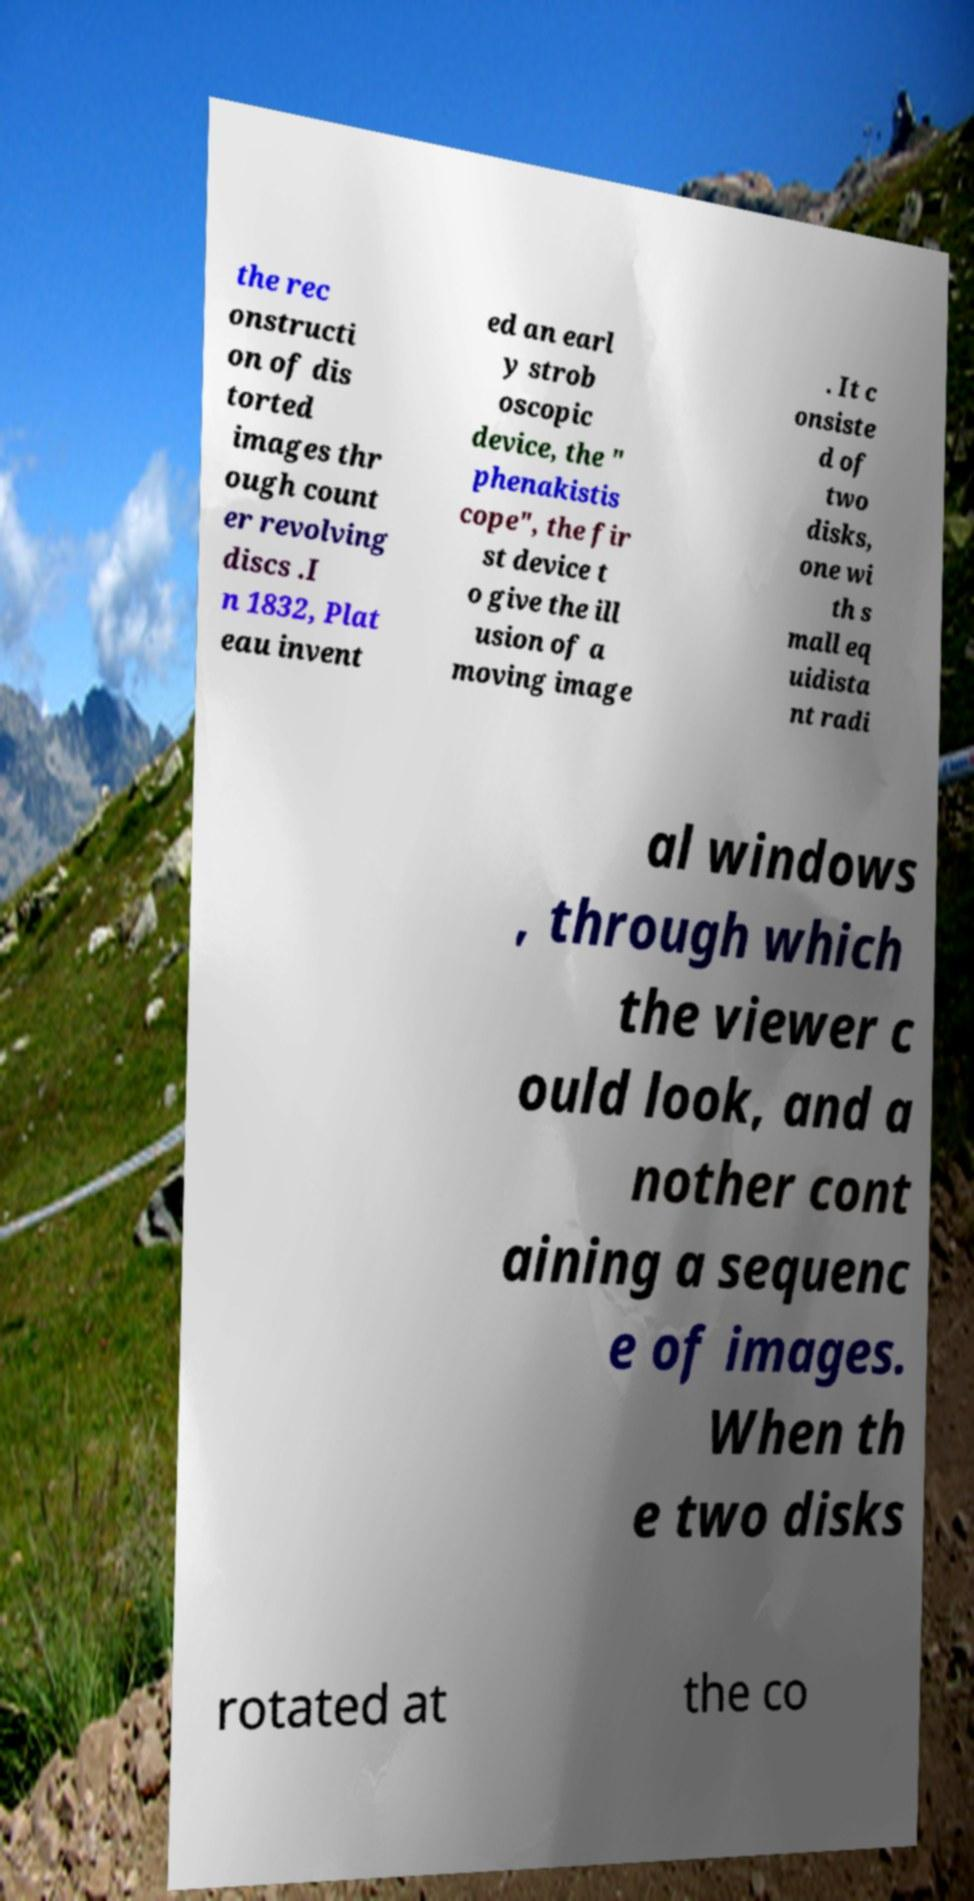What messages or text are displayed in this image? I need them in a readable, typed format. the rec onstructi on of dis torted images thr ough count er revolving discs .I n 1832, Plat eau invent ed an earl y strob oscopic device, the " phenakistis cope", the fir st device t o give the ill usion of a moving image . It c onsiste d of two disks, one wi th s mall eq uidista nt radi al windows , through which the viewer c ould look, and a nother cont aining a sequenc e of images. When th e two disks rotated at the co 